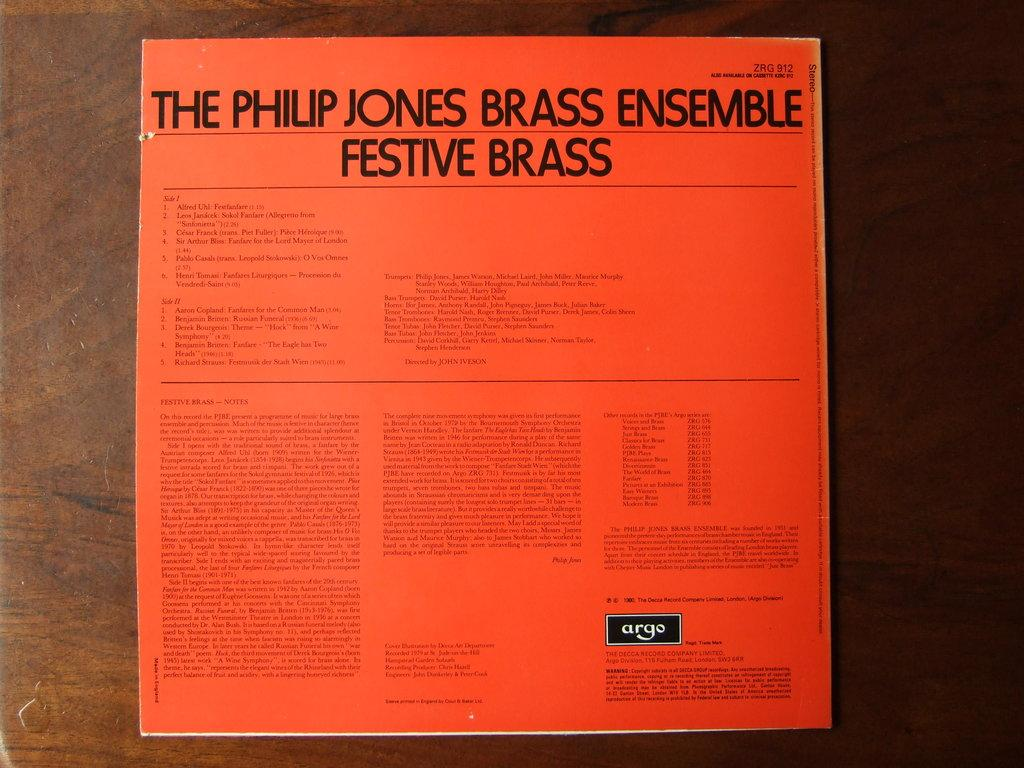<image>
Summarize the visual content of the image. a record booklet that says 'the philip jones brass ensemble' on it 